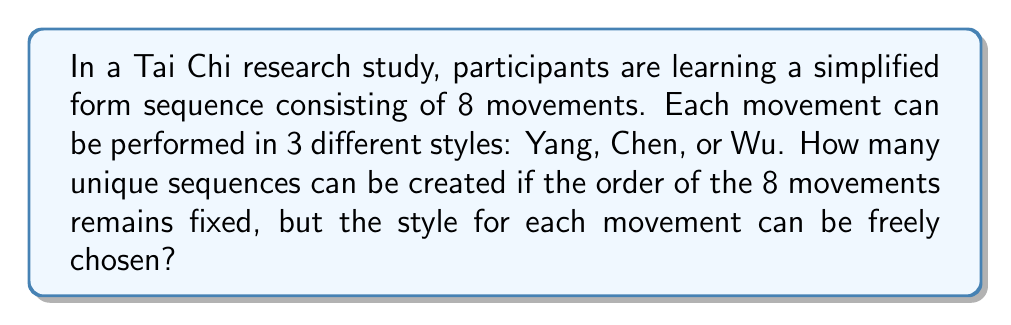Teach me how to tackle this problem. To solve this problem, we'll follow these steps:

1. Understand the given information:
   - The sequence consists of 8 movements
   - Each movement can be performed in 3 different styles
   - The order of movements is fixed, but the style for each can vary

2. Recognize this as a combination problem:
   - For each movement, we have 3 choices of style
   - We need to make this choice 8 times (once for each movement)

3. Apply the multiplication principle:
   - When we have a series of independent choices, we multiply the number of options for each choice
   - In this case, we have 3 choices for each of the 8 movements

4. Calculate the total number of combinations:
   $$3^8 = 3 \times 3 \times 3 \times 3 \times 3 \times 3 \times 3 \times 3 = 6,561$$

Therefore, there are 6,561 unique sequences that can be created by varying the style of each movement in the 8-movement Tai Chi form.

This large number of combinations could be relevant to your psychology research, as it demonstrates the potential for variety in Tai Chi practice, which might influence participants' engagement, learning processes, and psychological responses to the mind-body practice.
Answer: $3^8 = 6,561$ unique sequences 